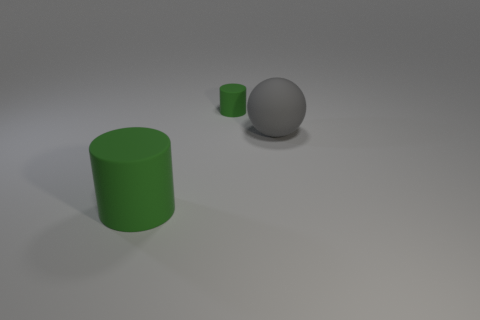Subtract all purple balls. Subtract all green blocks. How many balls are left? 1 Add 2 big yellow matte balls. How many objects exist? 5 Subtract all cylinders. How many objects are left? 1 Add 3 tiny cylinders. How many tiny cylinders are left? 4 Add 2 spheres. How many spheres exist? 3 Subtract 0 red spheres. How many objects are left? 3 Subtract all yellow cylinders. Subtract all big things. How many objects are left? 1 